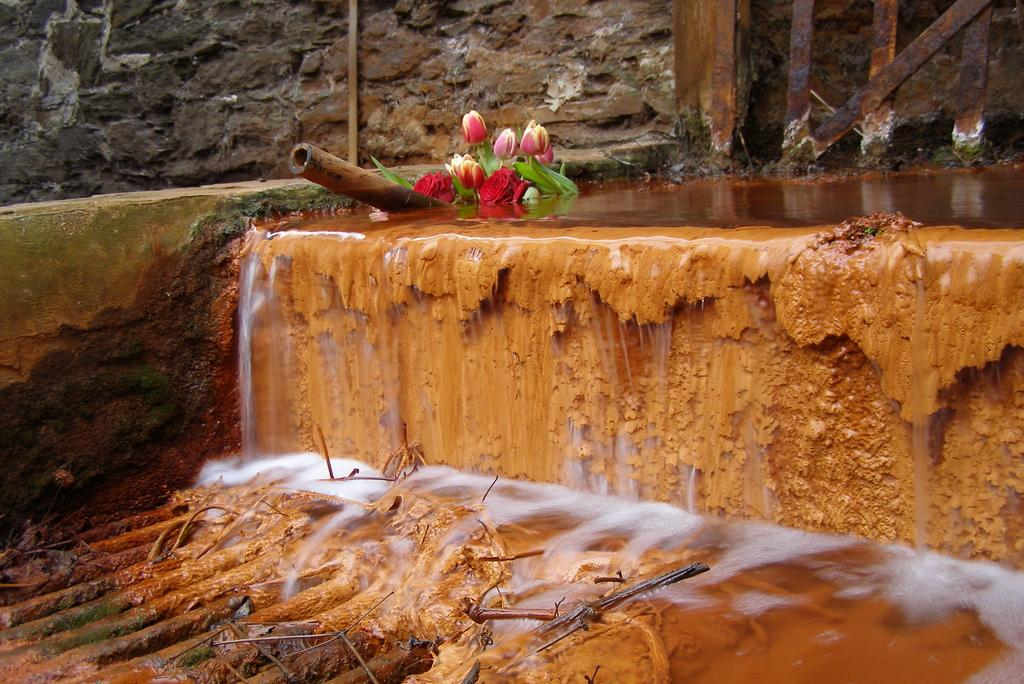What natural feature is the main subject of the image? There is a waterfall in the image. What can be seen at the base of the waterfall? There are objects at the bottom of the waterfall. What type of flora is visible in the image? There are flowers visible in the image. What man-made structures are present in the image? There is a pole, a wall, and a metal fence in the image. What type of veil is draped over the waterfall in the image? There is no veil present in the image; it features a waterfall with objects at the bottom, flowers, a pole, a wall, and a metal fence. How many toes can be seen in the image? There are no visible toes in the image. 